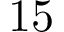Convert formula to latex. <formula><loc_0><loc_0><loc_500><loc_500>1 5</formula> 